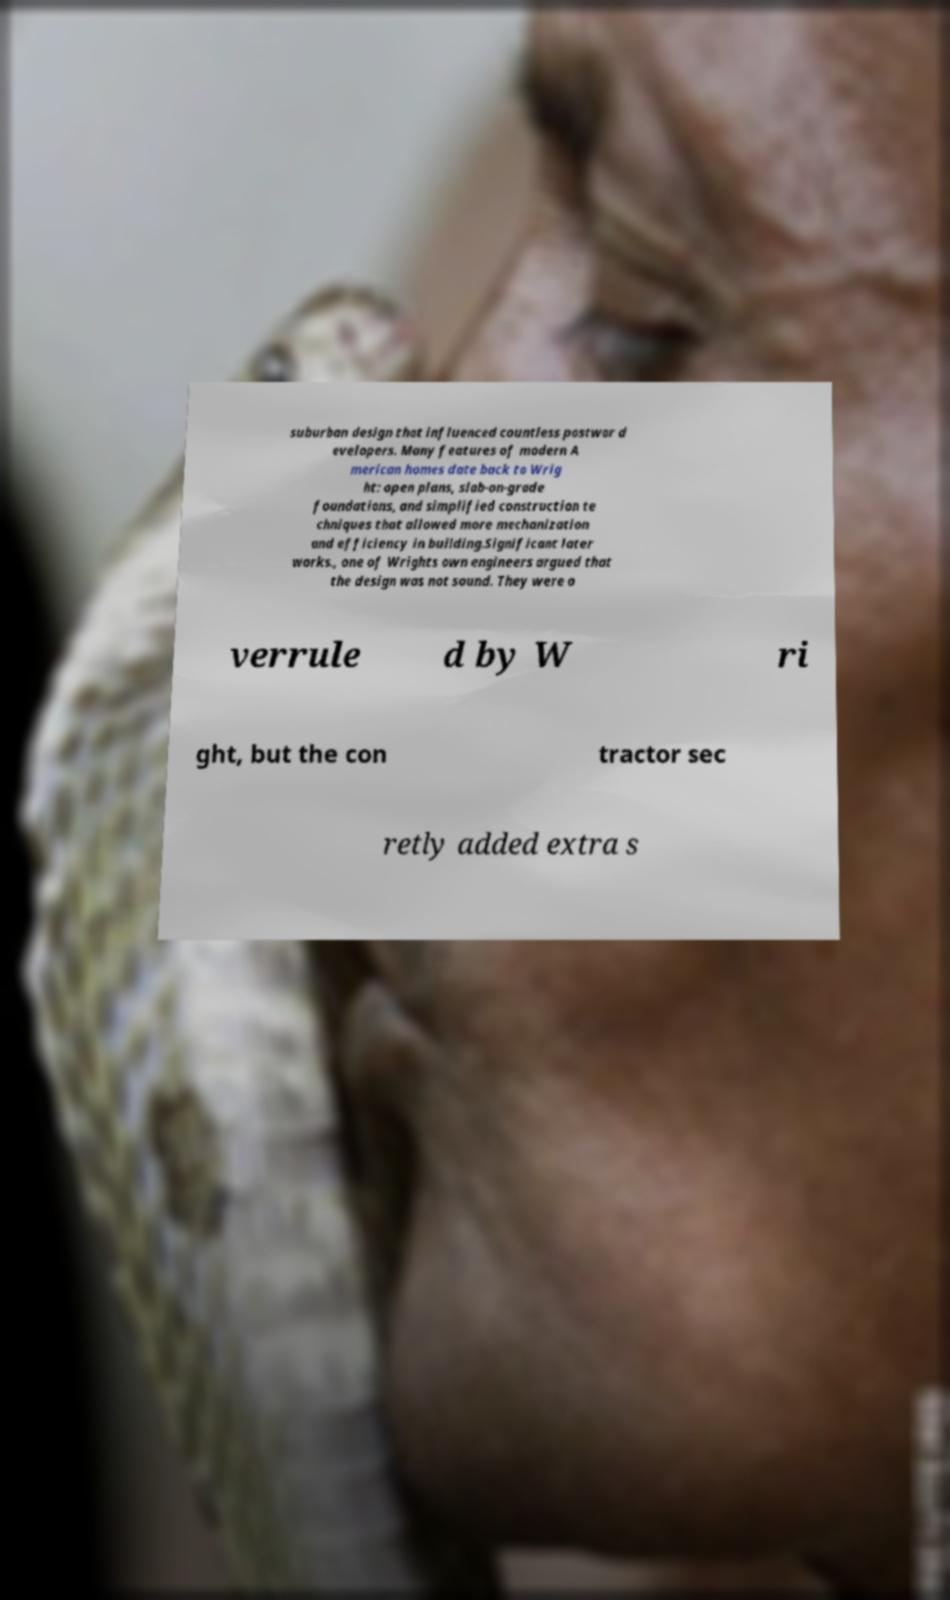Could you extract and type out the text from this image? suburban design that influenced countless postwar d evelopers. Many features of modern A merican homes date back to Wrig ht: open plans, slab-on-grade foundations, and simplified construction te chniques that allowed more mechanization and efficiency in building.Significant later works., one of Wrights own engineers argued that the design was not sound. They were o verrule d by W ri ght, but the con tractor sec retly added extra s 